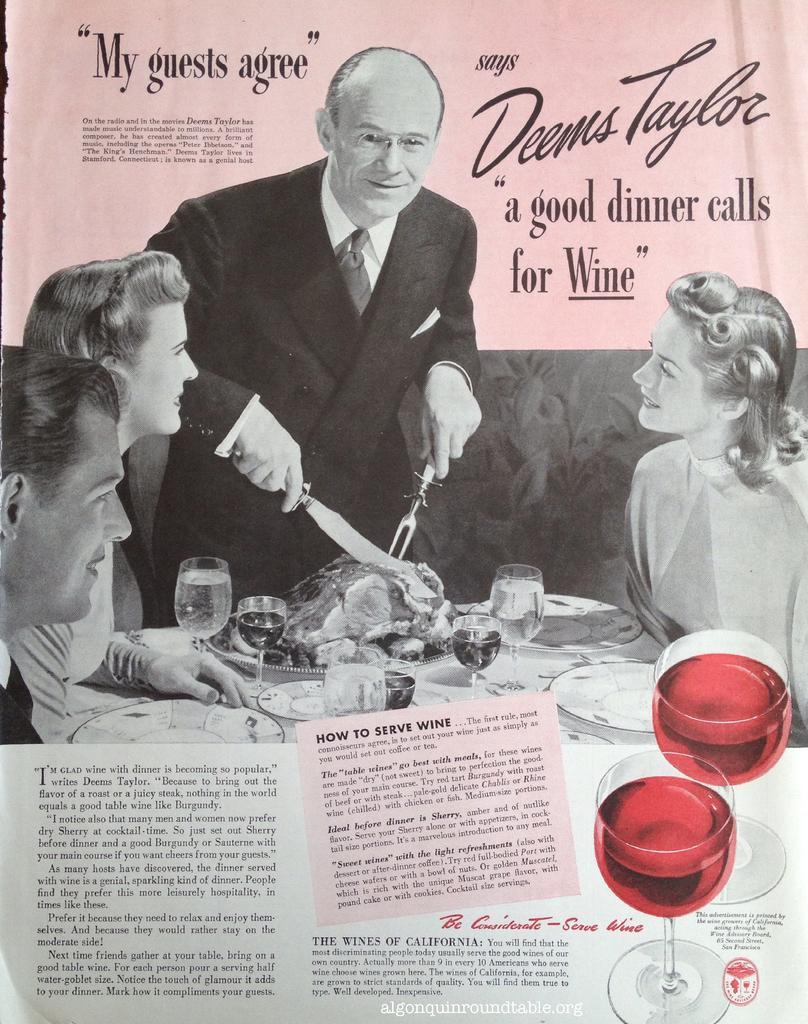Describe this image in one or two sentences. In this picture we can see poster, on this poster we can see people and we can see glasses, plates and food on the table and some information. 